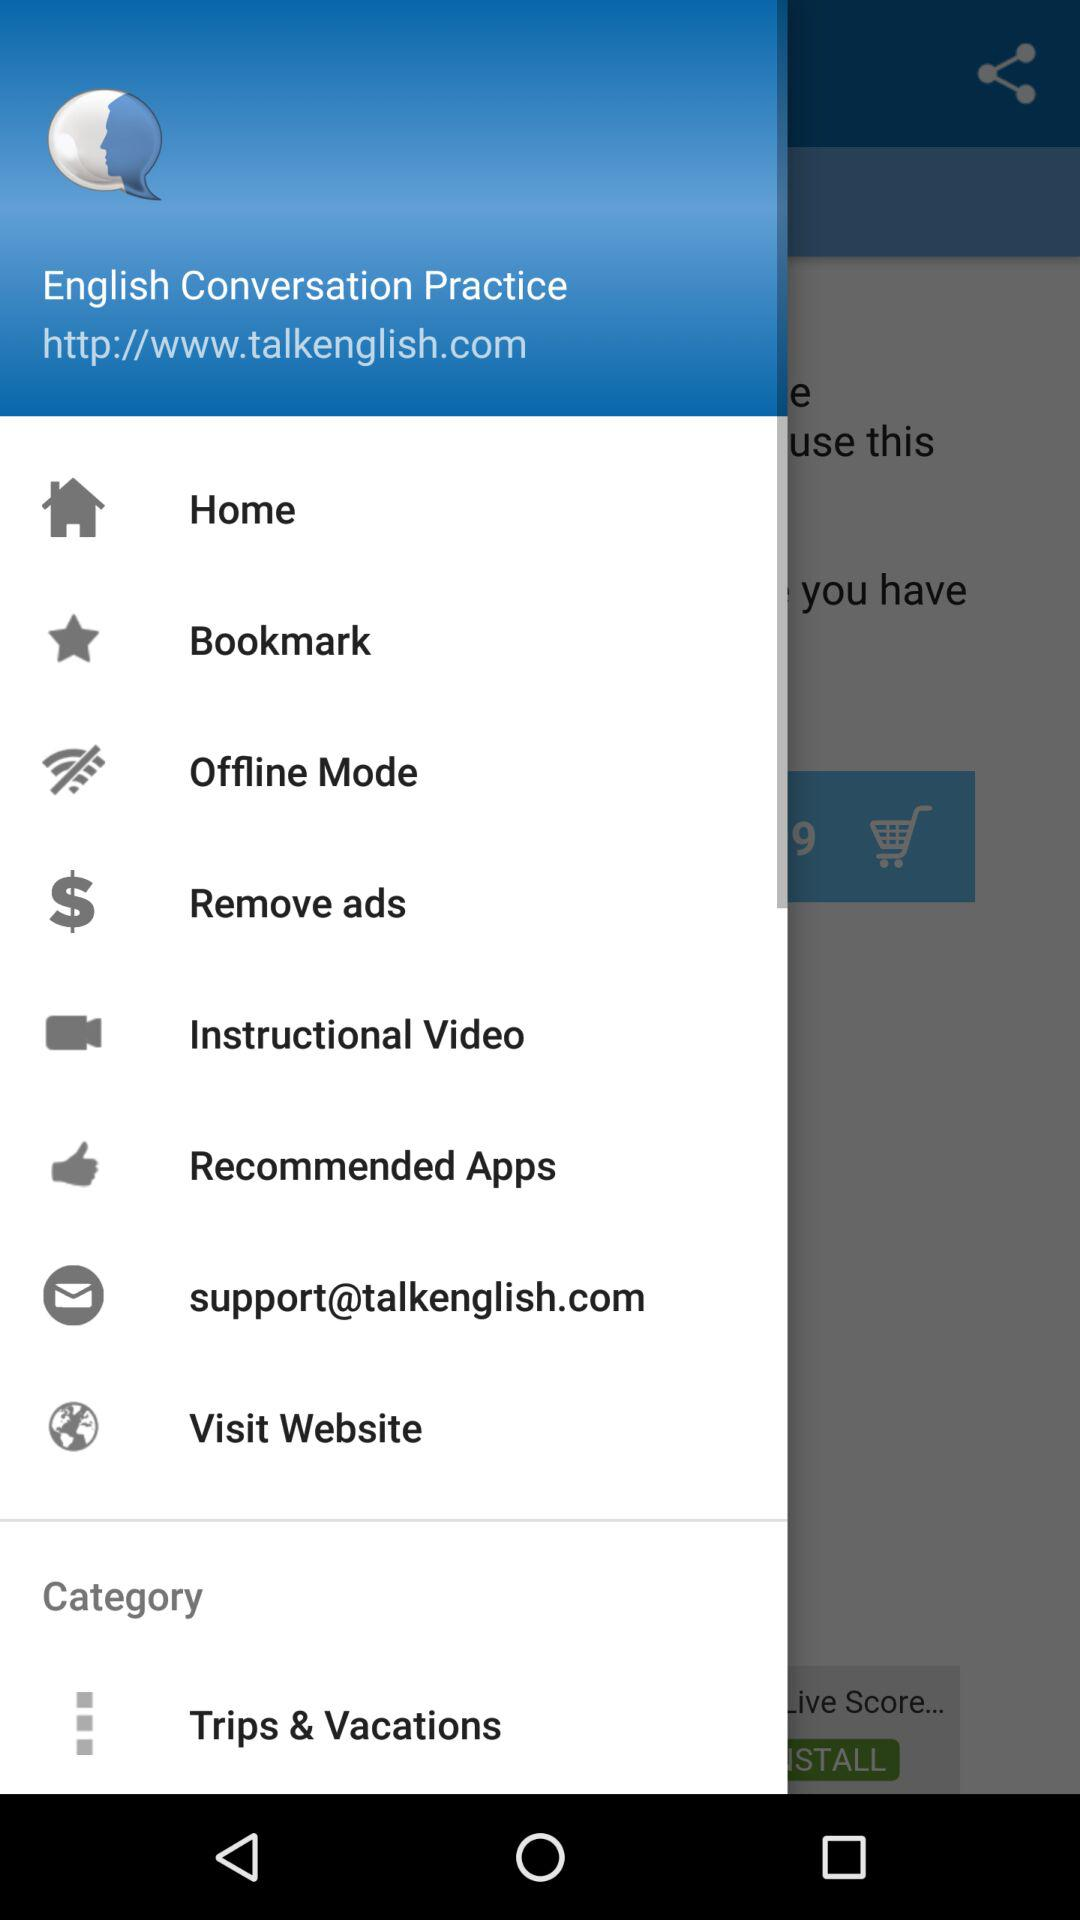What is the support website for this application? The support website is support@talkenglish.com. 